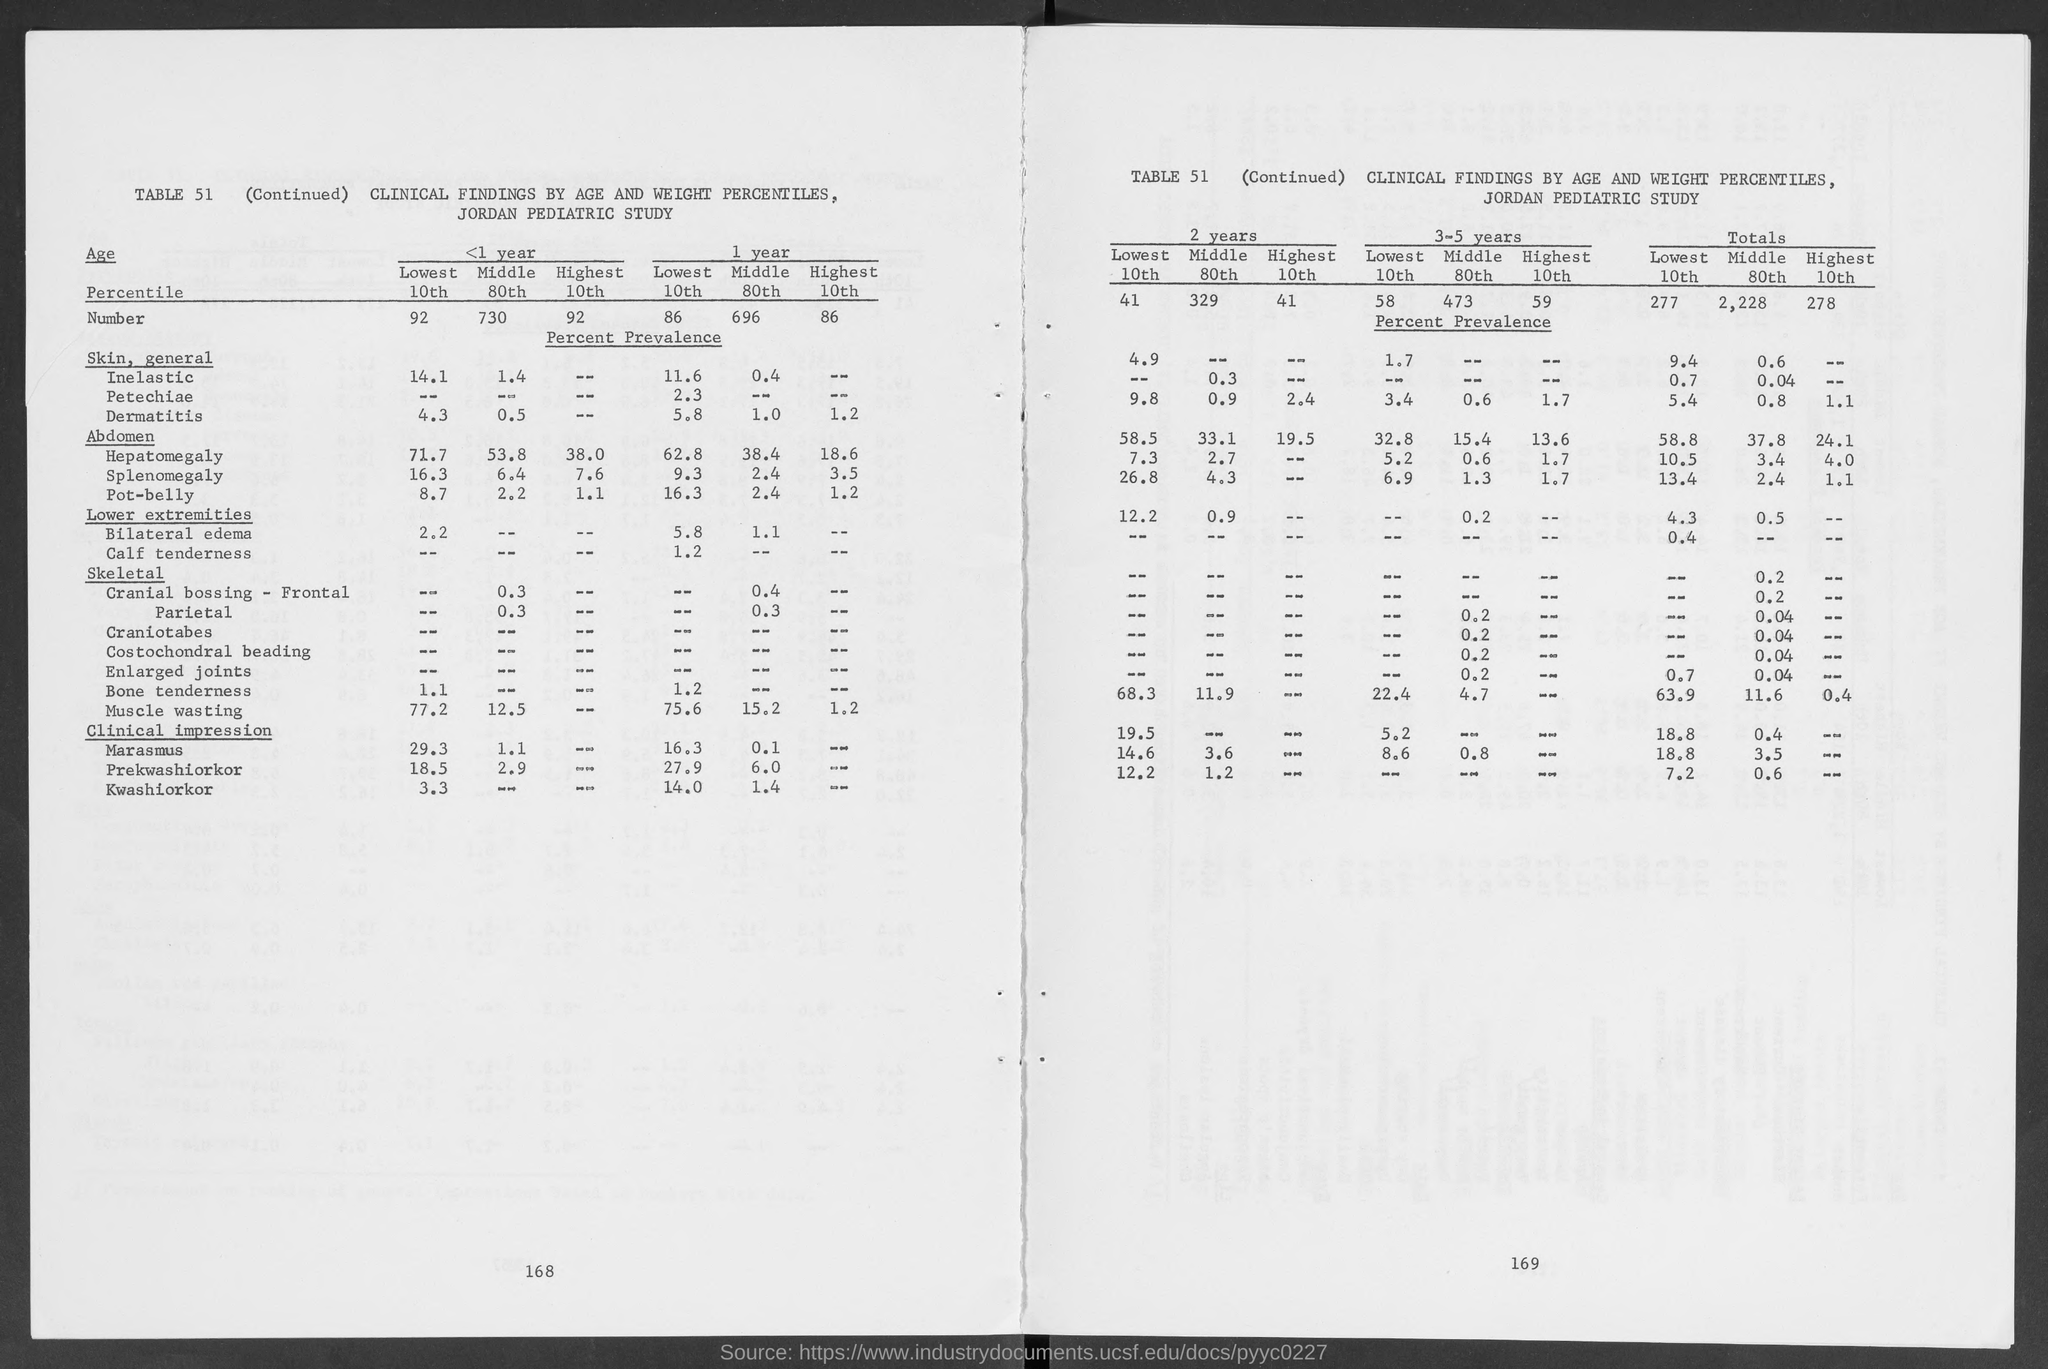Outline some significant characteristics in this image. The number of the highest 10th grade student in the first year is 86. The number of the lowest 10th in the first year is 86. The total number of "highest 10th" is 278. The total number of the lowest 10th is 277. This means that out of the total number of 10th pass students, the number of students who have scored the lowest is 277. The total number of "middle 80th" is 2,228. 